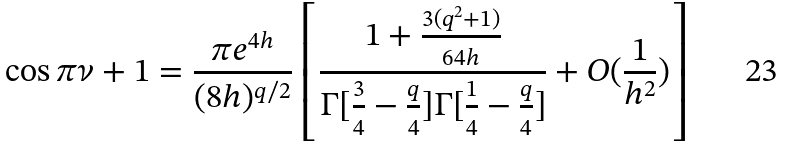Convert formula to latex. <formula><loc_0><loc_0><loc_500><loc_500>\cos \pi \nu + 1 = \frac { \pi e ^ { 4 h } } { ( 8 h ) ^ { q / 2 } } \left [ \frac { 1 + \frac { 3 ( q ^ { 2 } + 1 ) } { 6 4 h } } { \Gamma [ \frac { 3 } { 4 } - \frac { q } { 4 } ] \Gamma [ \frac { 1 } { 4 } - \frac { q } { 4 } ] } + O ( \frac { 1 } { h ^ { 2 } } ) \right ]</formula> 